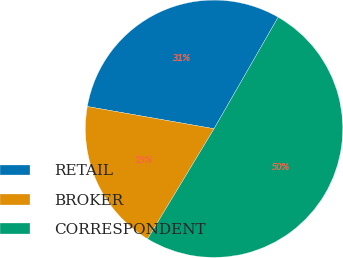Convert chart. <chart><loc_0><loc_0><loc_500><loc_500><pie_chart><fcel>RETAIL<fcel>BROKER<fcel>CORRESPONDENT<nl><fcel>30.54%<fcel>19.13%<fcel>50.34%<nl></chart> 